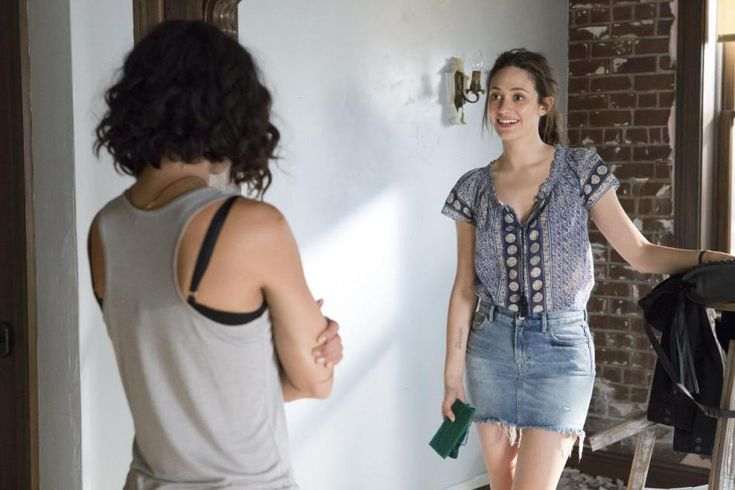Tell a detailed story behind this moment. In a sunlit apartment on a lazy Saturday afternoon, Emma and Lisa reunite after months of being apart due to their busy schedules. Emma, who has just returned from a volunteer trip abroad, shares her exciting experiences with Lisa, who listens intently. The room echoes with laughter as they reminisce about old times. Emma, wearing a denim skirt and a dotted blouse, holds a green book filled with photographs from her trip, which she plans to gift to Lisa. The rustic brick wall and minimalist decor serve as the perfect backdrop for their heartfelt conversation, emphasizing the warmth and authenticity of their friendship. This captured moment is a small, yet precious chapter in their long-standing bond, filled with shared stories and mutual support. 